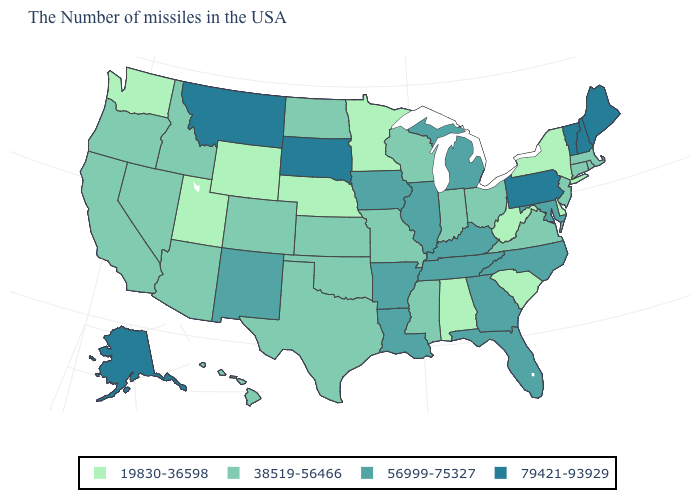Does the map have missing data?
Concise answer only. No. What is the value of Wisconsin?
Keep it brief. 38519-56466. What is the value of Ohio?
Write a very short answer. 38519-56466. Name the states that have a value in the range 79421-93929?
Keep it brief. Maine, New Hampshire, Vermont, Pennsylvania, South Dakota, Montana, Alaska. Name the states that have a value in the range 79421-93929?
Short answer required. Maine, New Hampshire, Vermont, Pennsylvania, South Dakota, Montana, Alaska. What is the value of New Hampshire?
Short answer required. 79421-93929. Name the states that have a value in the range 19830-36598?
Answer briefly. New York, Delaware, South Carolina, West Virginia, Alabama, Minnesota, Nebraska, Wyoming, Utah, Washington. Is the legend a continuous bar?
Give a very brief answer. No. Is the legend a continuous bar?
Keep it brief. No. What is the value of Delaware?
Short answer required. 19830-36598. Name the states that have a value in the range 19830-36598?
Quick response, please. New York, Delaware, South Carolina, West Virginia, Alabama, Minnesota, Nebraska, Wyoming, Utah, Washington. Does Utah have the highest value in the USA?
Keep it brief. No. Does Washington have a lower value than Maryland?
Answer briefly. Yes. What is the value of North Carolina?
Concise answer only. 56999-75327. 